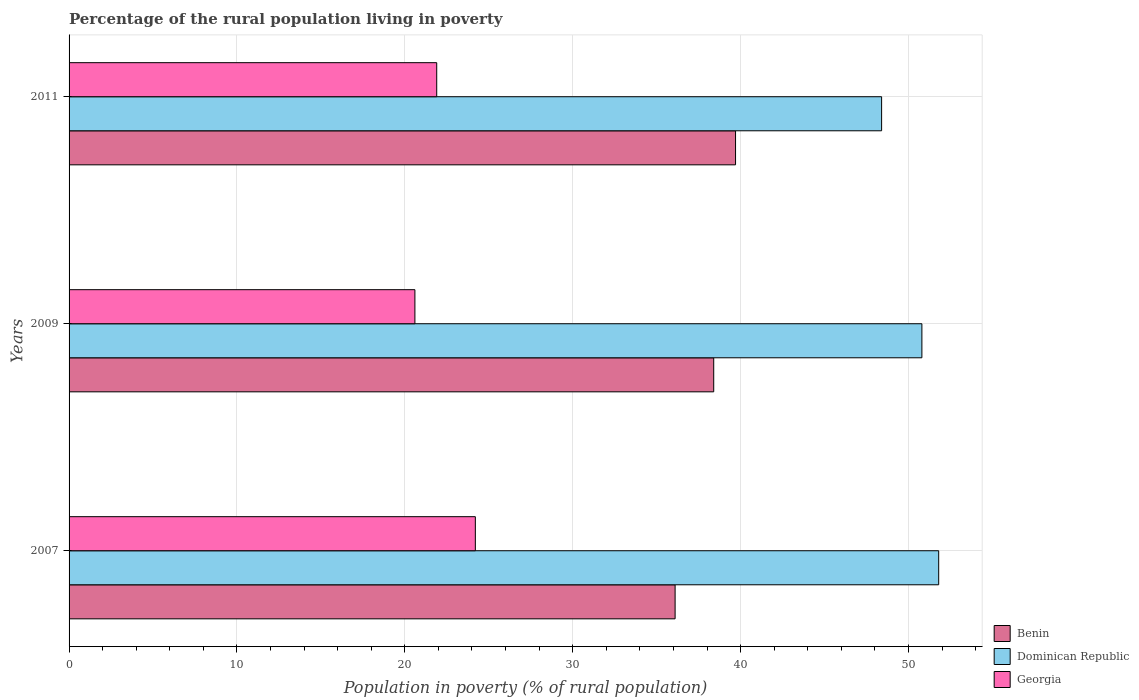How many groups of bars are there?
Make the answer very short. 3. How many bars are there on the 3rd tick from the bottom?
Your response must be concise. 3. What is the percentage of the rural population living in poverty in Benin in 2009?
Give a very brief answer. 38.4. Across all years, what is the maximum percentage of the rural population living in poverty in Georgia?
Your response must be concise. 24.2. Across all years, what is the minimum percentage of the rural population living in poverty in Georgia?
Make the answer very short. 20.6. In which year was the percentage of the rural population living in poverty in Benin maximum?
Keep it short and to the point. 2011. In which year was the percentage of the rural population living in poverty in Dominican Republic minimum?
Offer a very short reply. 2011. What is the total percentage of the rural population living in poverty in Georgia in the graph?
Offer a very short reply. 66.7. What is the difference between the percentage of the rural population living in poverty in Dominican Republic in 2007 and that in 2011?
Offer a terse response. 3.4. What is the difference between the percentage of the rural population living in poverty in Georgia in 2009 and the percentage of the rural population living in poverty in Dominican Republic in 2011?
Your response must be concise. -27.8. What is the average percentage of the rural population living in poverty in Georgia per year?
Make the answer very short. 22.23. In the year 2011, what is the difference between the percentage of the rural population living in poverty in Benin and percentage of the rural population living in poverty in Georgia?
Offer a very short reply. 17.8. What is the ratio of the percentage of the rural population living in poverty in Georgia in 2007 to that in 2011?
Make the answer very short. 1.11. Is the percentage of the rural population living in poverty in Dominican Republic in 2009 less than that in 2011?
Provide a short and direct response. No. What is the difference between the highest and the second highest percentage of the rural population living in poverty in Georgia?
Give a very brief answer. 2.3. What is the difference between the highest and the lowest percentage of the rural population living in poverty in Dominican Republic?
Offer a very short reply. 3.4. Is the sum of the percentage of the rural population living in poverty in Dominican Republic in 2007 and 2009 greater than the maximum percentage of the rural population living in poverty in Georgia across all years?
Offer a very short reply. Yes. What does the 2nd bar from the top in 2007 represents?
Keep it short and to the point. Dominican Republic. What does the 2nd bar from the bottom in 2009 represents?
Provide a short and direct response. Dominican Republic. What is the difference between two consecutive major ticks on the X-axis?
Offer a very short reply. 10. Are the values on the major ticks of X-axis written in scientific E-notation?
Your answer should be very brief. No. Does the graph contain any zero values?
Offer a terse response. No. Does the graph contain grids?
Offer a very short reply. Yes. Where does the legend appear in the graph?
Give a very brief answer. Bottom right. How many legend labels are there?
Keep it short and to the point. 3. How are the legend labels stacked?
Offer a terse response. Vertical. What is the title of the graph?
Provide a succinct answer. Percentage of the rural population living in poverty. What is the label or title of the X-axis?
Your answer should be very brief. Population in poverty (% of rural population). What is the Population in poverty (% of rural population) in Benin in 2007?
Make the answer very short. 36.1. What is the Population in poverty (% of rural population) of Dominican Republic in 2007?
Make the answer very short. 51.8. What is the Population in poverty (% of rural population) in Georgia in 2007?
Provide a short and direct response. 24.2. What is the Population in poverty (% of rural population) of Benin in 2009?
Keep it short and to the point. 38.4. What is the Population in poverty (% of rural population) in Dominican Republic in 2009?
Your answer should be compact. 50.8. What is the Population in poverty (% of rural population) of Georgia in 2009?
Ensure brevity in your answer.  20.6. What is the Population in poverty (% of rural population) in Benin in 2011?
Ensure brevity in your answer.  39.7. What is the Population in poverty (% of rural population) in Dominican Republic in 2011?
Ensure brevity in your answer.  48.4. What is the Population in poverty (% of rural population) in Georgia in 2011?
Your response must be concise. 21.9. Across all years, what is the maximum Population in poverty (% of rural population) in Benin?
Your answer should be compact. 39.7. Across all years, what is the maximum Population in poverty (% of rural population) in Dominican Republic?
Your answer should be very brief. 51.8. Across all years, what is the maximum Population in poverty (% of rural population) in Georgia?
Make the answer very short. 24.2. Across all years, what is the minimum Population in poverty (% of rural population) of Benin?
Give a very brief answer. 36.1. Across all years, what is the minimum Population in poverty (% of rural population) in Dominican Republic?
Make the answer very short. 48.4. Across all years, what is the minimum Population in poverty (% of rural population) of Georgia?
Keep it short and to the point. 20.6. What is the total Population in poverty (% of rural population) of Benin in the graph?
Your answer should be very brief. 114.2. What is the total Population in poverty (% of rural population) of Dominican Republic in the graph?
Your answer should be very brief. 151. What is the total Population in poverty (% of rural population) in Georgia in the graph?
Your answer should be very brief. 66.7. What is the difference between the Population in poverty (% of rural population) of Benin in 2007 and that in 2009?
Your answer should be very brief. -2.3. What is the difference between the Population in poverty (% of rural population) of Georgia in 2007 and that in 2011?
Keep it short and to the point. 2.3. What is the difference between the Population in poverty (% of rural population) in Benin in 2009 and that in 2011?
Ensure brevity in your answer.  -1.3. What is the difference between the Population in poverty (% of rural population) of Benin in 2007 and the Population in poverty (% of rural population) of Dominican Republic in 2009?
Ensure brevity in your answer.  -14.7. What is the difference between the Population in poverty (% of rural population) in Benin in 2007 and the Population in poverty (% of rural population) in Georgia in 2009?
Offer a terse response. 15.5. What is the difference between the Population in poverty (% of rural population) in Dominican Republic in 2007 and the Population in poverty (% of rural population) in Georgia in 2009?
Offer a terse response. 31.2. What is the difference between the Population in poverty (% of rural population) in Benin in 2007 and the Population in poverty (% of rural population) in Dominican Republic in 2011?
Make the answer very short. -12.3. What is the difference between the Population in poverty (% of rural population) in Dominican Republic in 2007 and the Population in poverty (% of rural population) in Georgia in 2011?
Your answer should be compact. 29.9. What is the difference between the Population in poverty (% of rural population) of Dominican Republic in 2009 and the Population in poverty (% of rural population) of Georgia in 2011?
Your answer should be very brief. 28.9. What is the average Population in poverty (% of rural population) in Benin per year?
Provide a succinct answer. 38.07. What is the average Population in poverty (% of rural population) of Dominican Republic per year?
Keep it short and to the point. 50.33. What is the average Population in poverty (% of rural population) in Georgia per year?
Give a very brief answer. 22.23. In the year 2007, what is the difference between the Population in poverty (% of rural population) of Benin and Population in poverty (% of rural population) of Dominican Republic?
Make the answer very short. -15.7. In the year 2007, what is the difference between the Population in poverty (% of rural population) of Benin and Population in poverty (% of rural population) of Georgia?
Ensure brevity in your answer.  11.9. In the year 2007, what is the difference between the Population in poverty (% of rural population) of Dominican Republic and Population in poverty (% of rural population) of Georgia?
Your answer should be compact. 27.6. In the year 2009, what is the difference between the Population in poverty (% of rural population) of Benin and Population in poverty (% of rural population) of Georgia?
Make the answer very short. 17.8. In the year 2009, what is the difference between the Population in poverty (% of rural population) of Dominican Republic and Population in poverty (% of rural population) of Georgia?
Keep it short and to the point. 30.2. What is the ratio of the Population in poverty (% of rural population) of Benin in 2007 to that in 2009?
Provide a succinct answer. 0.94. What is the ratio of the Population in poverty (% of rural population) of Dominican Republic in 2007 to that in 2009?
Offer a very short reply. 1.02. What is the ratio of the Population in poverty (% of rural population) of Georgia in 2007 to that in 2009?
Give a very brief answer. 1.17. What is the ratio of the Population in poverty (% of rural population) of Benin in 2007 to that in 2011?
Offer a terse response. 0.91. What is the ratio of the Population in poverty (% of rural population) of Dominican Republic in 2007 to that in 2011?
Ensure brevity in your answer.  1.07. What is the ratio of the Population in poverty (% of rural population) of Georgia in 2007 to that in 2011?
Offer a very short reply. 1.1. What is the ratio of the Population in poverty (% of rural population) of Benin in 2009 to that in 2011?
Your answer should be compact. 0.97. What is the ratio of the Population in poverty (% of rural population) of Dominican Republic in 2009 to that in 2011?
Offer a very short reply. 1.05. What is the ratio of the Population in poverty (% of rural population) in Georgia in 2009 to that in 2011?
Provide a succinct answer. 0.94. What is the difference between the highest and the second highest Population in poverty (% of rural population) of Benin?
Your answer should be very brief. 1.3. What is the difference between the highest and the second highest Population in poverty (% of rural population) of Dominican Republic?
Your response must be concise. 1. What is the difference between the highest and the lowest Population in poverty (% of rural population) of Benin?
Offer a terse response. 3.6. 